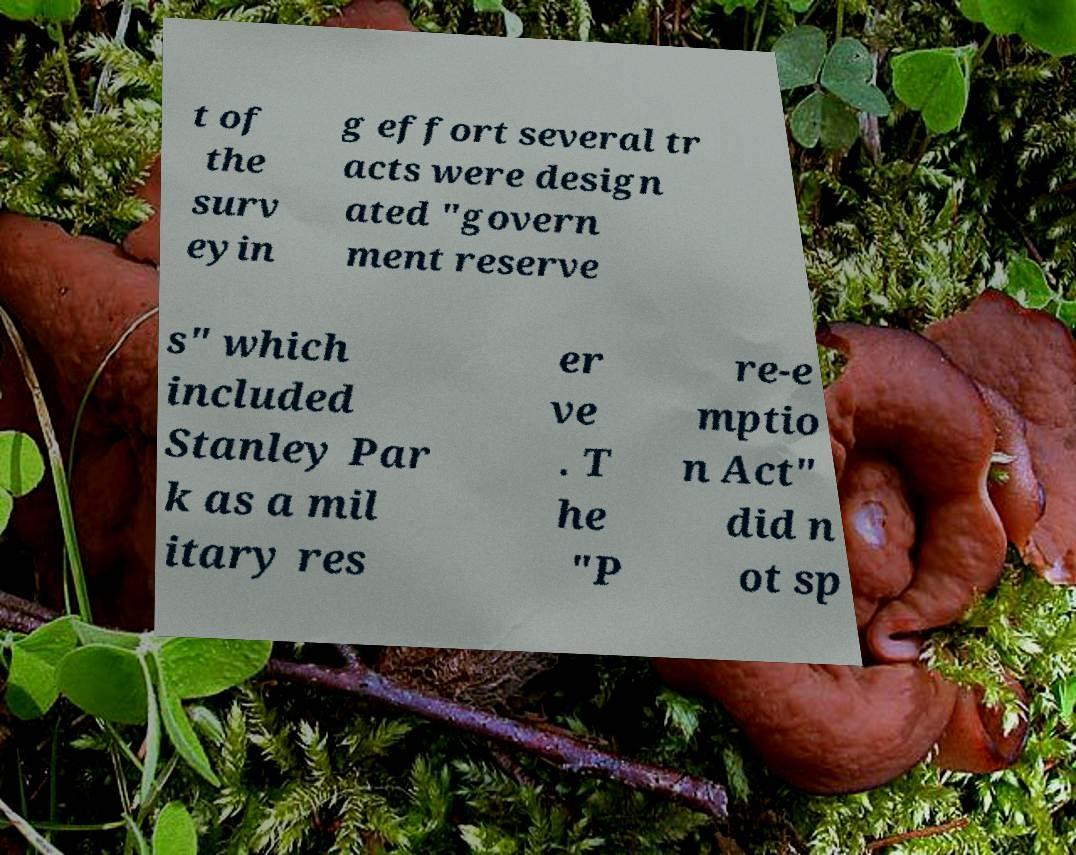Please identify and transcribe the text found in this image. t of the surv eyin g effort several tr acts were design ated "govern ment reserve s" which included Stanley Par k as a mil itary res er ve . T he "P re-e mptio n Act" did n ot sp 